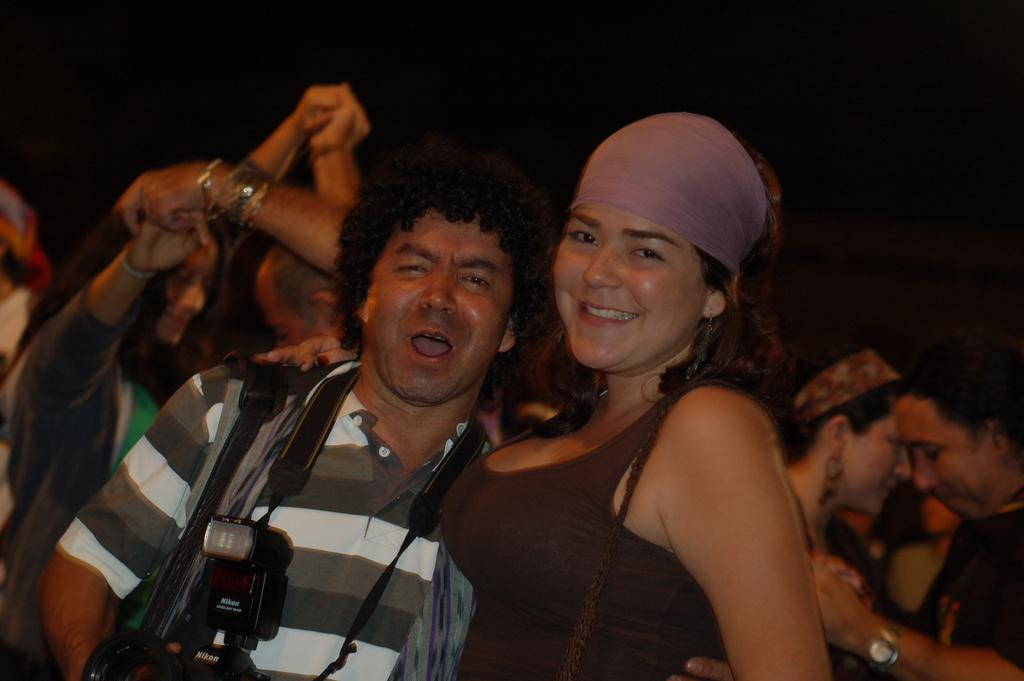Who is present in the image? There is a woman and a man in the image. What are the facial expressions of the individuals in the image? The woman and the man are both smiling. What is the man holding in the image? The man is holding a camera. What activity is happening in the background of the image? People are dancing in the background of the image. How would you describe the lighting in the image? The background of the image is dark. How does the woman's leg compare to the man's leg in the image? There is no information provided about the legs of the individuals in the image, so it is not possible to make a comparison. --- Facts: 1. There is a car in the image. 2. The car is red. 3. The car has four wheels. 4. There is a road in the image. 5. The road is paved. Absurd Topics: bird, ocean, mountain Conversation: What is the main subject of the image? The main subject of the image is a car. What color is the car? The car is red. How many wheels does the car have? The car has four wheels. What type of surface is the car on? There is a road in the image, and it is paved. Reasoning: Let's think step by step in order to produce the conversation. We start by identifying the main subject of the image, which is the car. Then, we describe the car's color and the number of wheels it has. Finally, we mention the type of surface the car is on, which is a paved road. Absurd Question/Answer: Can you see any birds flying over the ocean in the image? There is no mention of birds, an ocean, or any flying objects in the image. The image only features a red car on a paved road. 